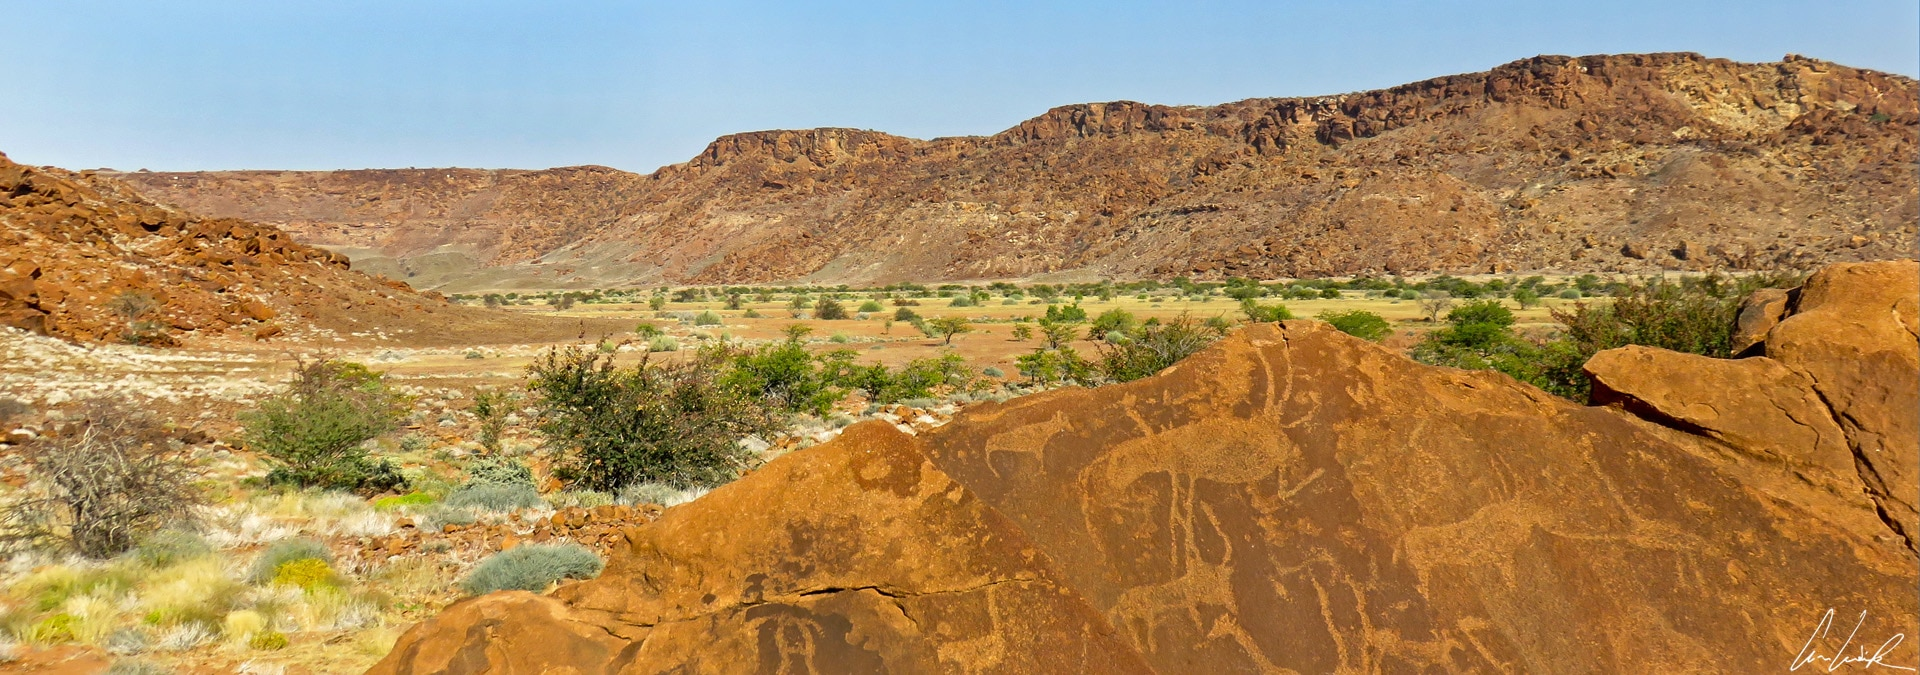If you were to imagine a mythological story inspired by this landscape, what would it be about? In a time long forgotten, the land of Twyfelfontein was guided by two powerful spirits, Uhambo the wanderer and Ikhanya the illuminator. Uhambo, a mighty giraffe, roamed the valleys, leaving a trail of wisdom in his hoofprints, while Ikhanya, the eagle, soared above, lighting the path with her radiant feathers. These spirits carved their stories into the stones, teaching the inhabitants about the cycles of life and the enduring power of the earth. One fateful day, an ominous darkness sought to consume the valley. Using the ancient carvings as beacons, Ikhanya channeled the light from her feathers through the engravings, filling the entire valley with a brilliant glow that banished the darkness forever. The engravings remain as a testament to their timeless guardianship, guiding all who walk there in the knowledge and light of Uhambo and Ikhanya. 